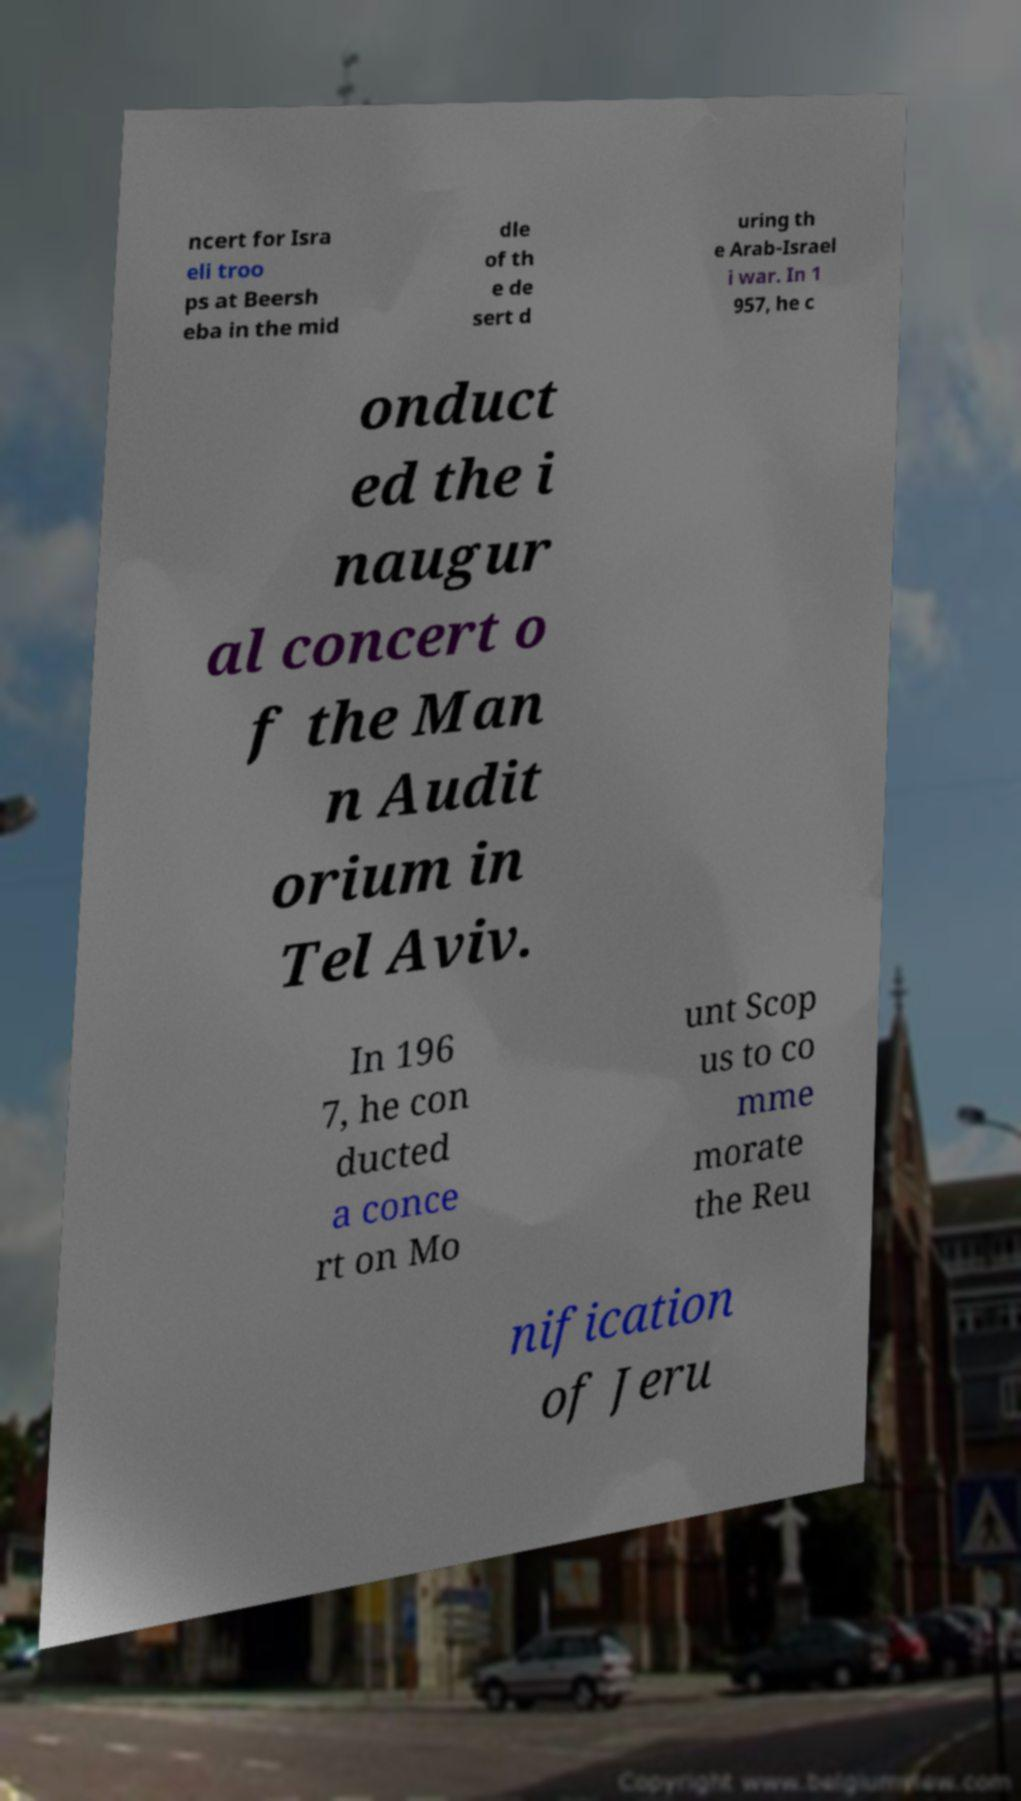Can you accurately transcribe the text from the provided image for me? ncert for Isra eli troo ps at Beersh eba in the mid dle of th e de sert d uring th e Arab-Israel i war. In 1 957, he c onduct ed the i naugur al concert o f the Man n Audit orium in Tel Aviv. In 196 7, he con ducted a conce rt on Mo unt Scop us to co mme morate the Reu nification of Jeru 